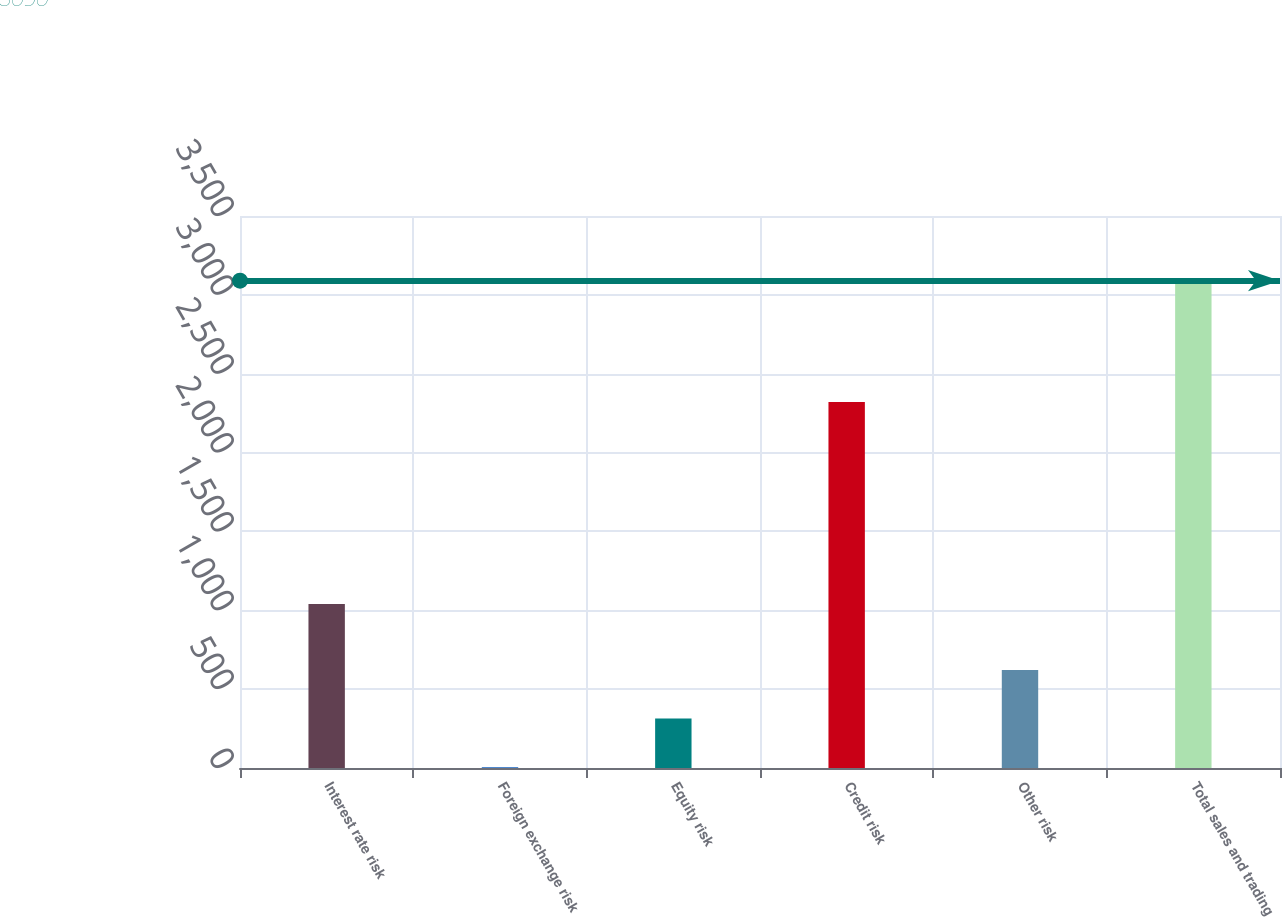<chart> <loc_0><loc_0><loc_500><loc_500><bar_chart><fcel>Interest rate risk<fcel>Foreign exchange risk<fcel>Equity risk<fcel>Credit risk<fcel>Other risk<fcel>Total sales and trading<nl><fcel>1040<fcel>5<fcel>313.5<fcel>2321<fcel>622<fcel>3090<nl></chart> 